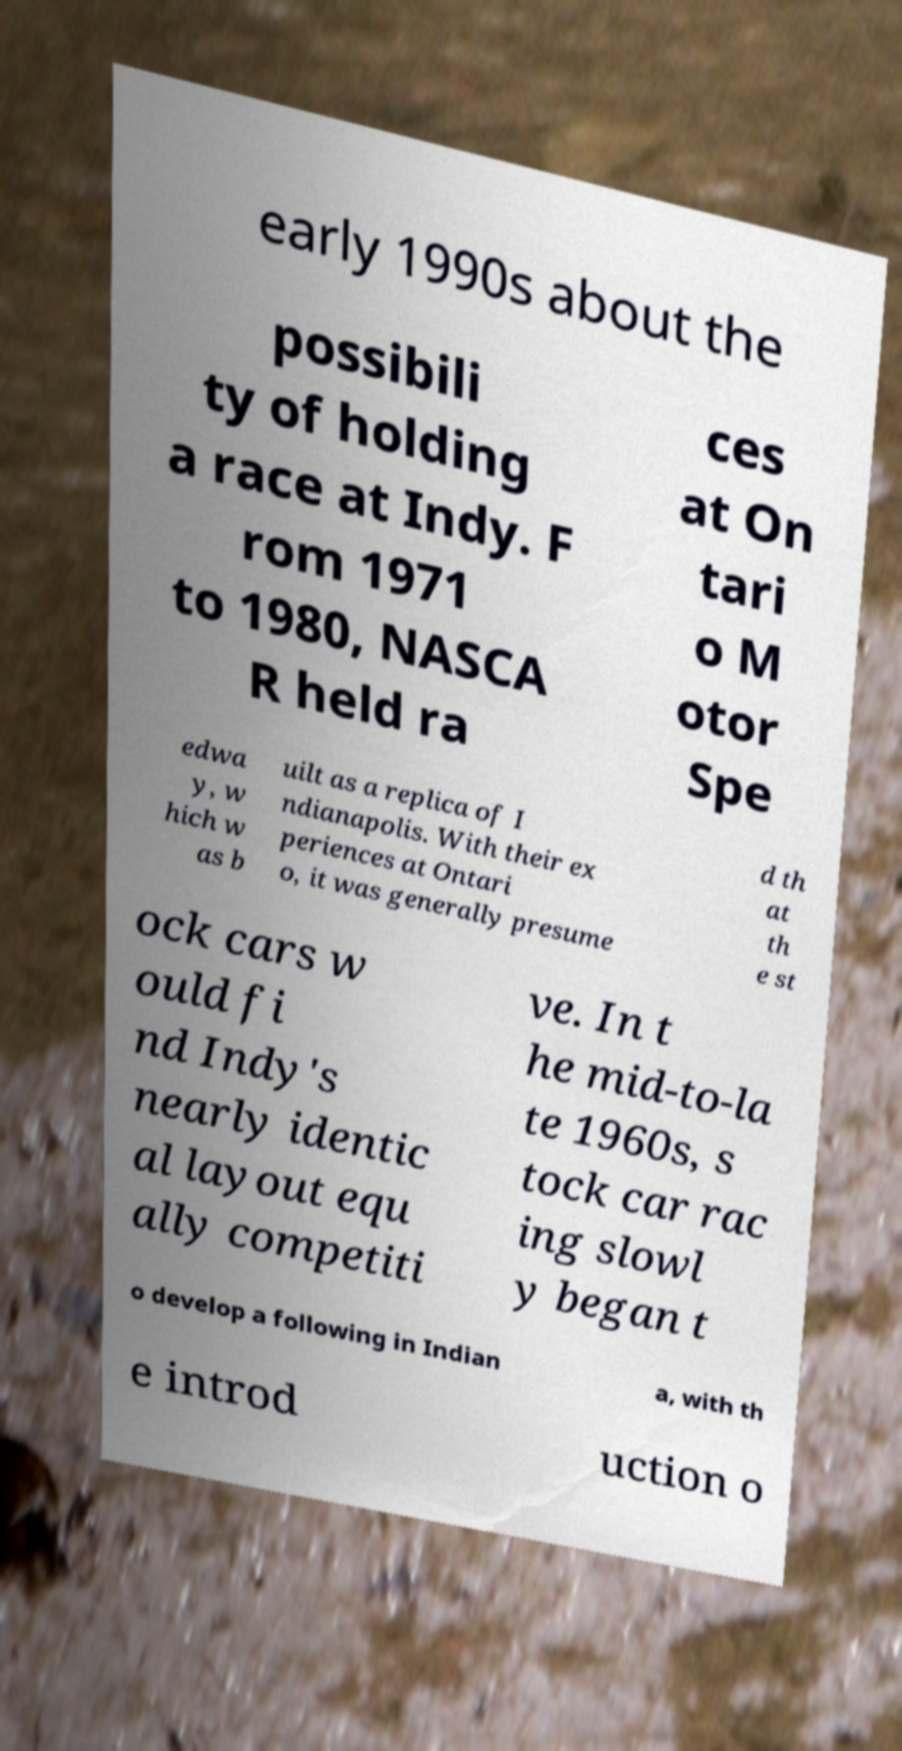Could you extract and type out the text from this image? early 1990s about the possibili ty of holding a race at Indy. F rom 1971 to 1980, NASCA R held ra ces at On tari o M otor Spe edwa y, w hich w as b uilt as a replica of I ndianapolis. With their ex periences at Ontari o, it was generally presume d th at th e st ock cars w ould fi nd Indy's nearly identic al layout equ ally competiti ve. In t he mid-to-la te 1960s, s tock car rac ing slowl y began t o develop a following in Indian a, with th e introd uction o 